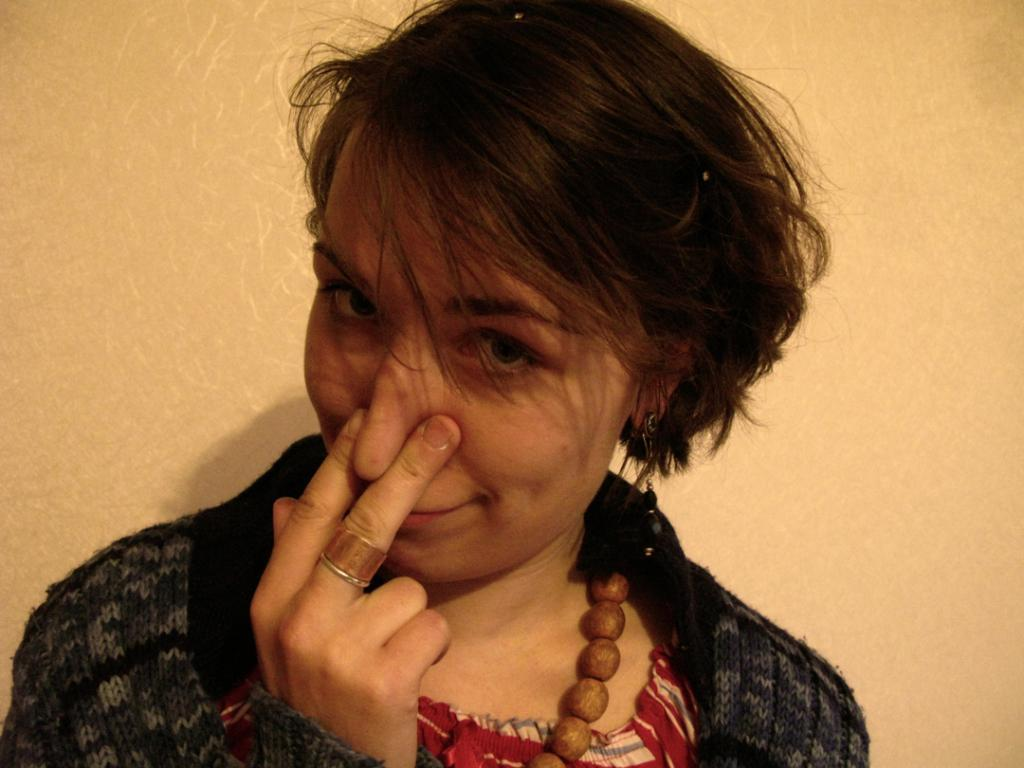Who is the main subject in the image? There is a woman in the image. Can you describe the woman's hairstyle? The woman has short hair. What is the woman wearing in the image? The woman is wearing a dress. What is the woman doing with her fingers in the image? The woman is holding her nose with her fingers. What can be seen in the background of the image? There is a wall in the background of the image. How many pets can be seen in the image? There are no pets visible in the image. What type of clam is the woman holding in the image? There is no clam present in the image. Is the woman standing on a slope in the image? There is no indication of a slope in the image. 